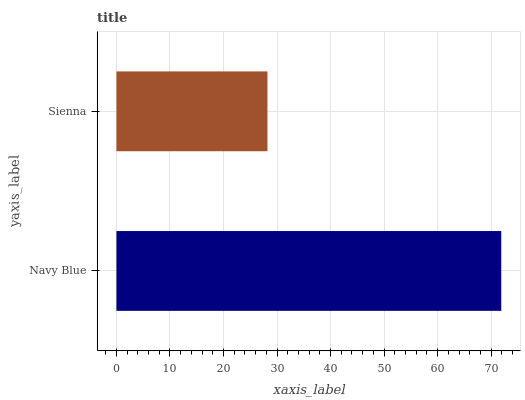Is Sienna the minimum?
Answer yes or no. Yes. Is Navy Blue the maximum?
Answer yes or no. Yes. Is Sienna the maximum?
Answer yes or no. No. Is Navy Blue greater than Sienna?
Answer yes or no. Yes. Is Sienna less than Navy Blue?
Answer yes or no. Yes. Is Sienna greater than Navy Blue?
Answer yes or no. No. Is Navy Blue less than Sienna?
Answer yes or no. No. Is Navy Blue the high median?
Answer yes or no. Yes. Is Sienna the low median?
Answer yes or no. Yes. Is Sienna the high median?
Answer yes or no. No. Is Navy Blue the low median?
Answer yes or no. No. 